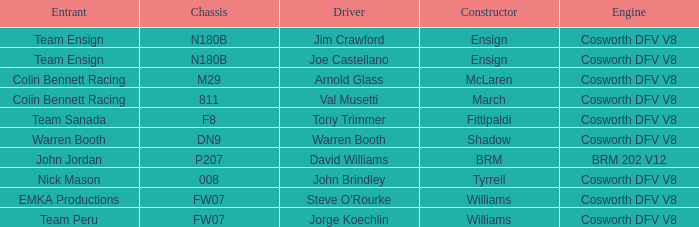Who built the Jim Crawford car? Ensign. 